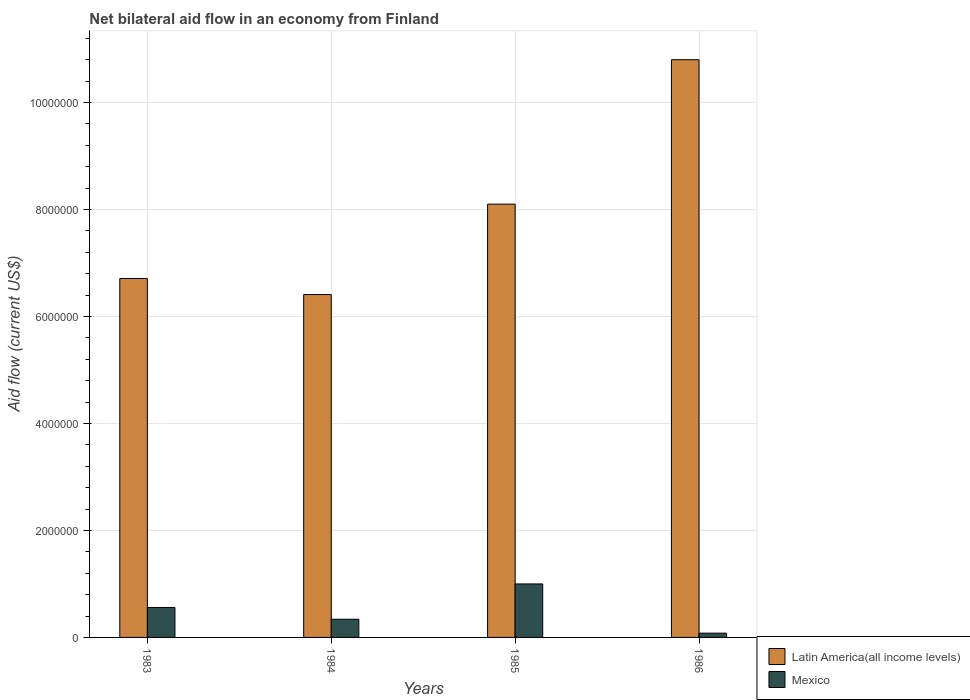How many bars are there on the 3rd tick from the right?
Give a very brief answer. 2. In how many cases, is the number of bars for a given year not equal to the number of legend labels?
Give a very brief answer. 0. Across all years, what is the maximum net bilateral aid flow in Latin America(all income levels)?
Ensure brevity in your answer.  1.08e+07. In which year was the net bilateral aid flow in Mexico maximum?
Keep it short and to the point. 1985. What is the total net bilateral aid flow in Mexico in the graph?
Provide a succinct answer. 1.98e+06. What is the difference between the net bilateral aid flow in Latin America(all income levels) in 1984 and that in 1986?
Provide a short and direct response. -4.39e+06. What is the difference between the net bilateral aid flow in Mexico in 1985 and the net bilateral aid flow in Latin America(all income levels) in 1984?
Keep it short and to the point. -5.41e+06. What is the average net bilateral aid flow in Latin America(all income levels) per year?
Give a very brief answer. 8.00e+06. In the year 1986, what is the difference between the net bilateral aid flow in Latin America(all income levels) and net bilateral aid flow in Mexico?
Your answer should be compact. 1.07e+07. In how many years, is the net bilateral aid flow in Latin America(all income levels) greater than 4400000 US$?
Provide a succinct answer. 4. Is the net bilateral aid flow in Mexico in 1984 less than that in 1985?
Ensure brevity in your answer.  Yes. Is the difference between the net bilateral aid flow in Latin America(all income levels) in 1983 and 1986 greater than the difference between the net bilateral aid flow in Mexico in 1983 and 1986?
Give a very brief answer. No. What is the difference between the highest and the second highest net bilateral aid flow in Mexico?
Offer a very short reply. 4.40e+05. What is the difference between the highest and the lowest net bilateral aid flow in Latin America(all income levels)?
Offer a very short reply. 4.39e+06. In how many years, is the net bilateral aid flow in Mexico greater than the average net bilateral aid flow in Mexico taken over all years?
Give a very brief answer. 2. What does the 1st bar from the right in 1984 represents?
Your response must be concise. Mexico. How many bars are there?
Your answer should be compact. 8. Are all the bars in the graph horizontal?
Offer a terse response. No. What is the difference between two consecutive major ticks on the Y-axis?
Give a very brief answer. 2.00e+06. Does the graph contain grids?
Your answer should be very brief. Yes. Where does the legend appear in the graph?
Provide a short and direct response. Bottom right. What is the title of the graph?
Give a very brief answer. Net bilateral aid flow in an economy from Finland. What is the label or title of the X-axis?
Offer a very short reply. Years. What is the Aid flow (current US$) of Latin America(all income levels) in 1983?
Make the answer very short. 6.71e+06. What is the Aid flow (current US$) in Mexico in 1983?
Your answer should be compact. 5.60e+05. What is the Aid flow (current US$) in Latin America(all income levels) in 1984?
Your answer should be very brief. 6.41e+06. What is the Aid flow (current US$) of Mexico in 1984?
Your answer should be compact. 3.40e+05. What is the Aid flow (current US$) in Latin America(all income levels) in 1985?
Your answer should be compact. 8.10e+06. What is the Aid flow (current US$) of Mexico in 1985?
Your response must be concise. 1.00e+06. What is the Aid flow (current US$) of Latin America(all income levels) in 1986?
Provide a short and direct response. 1.08e+07. What is the Aid flow (current US$) of Mexico in 1986?
Make the answer very short. 8.00e+04. Across all years, what is the maximum Aid flow (current US$) of Latin America(all income levels)?
Your answer should be very brief. 1.08e+07. Across all years, what is the maximum Aid flow (current US$) in Mexico?
Provide a short and direct response. 1.00e+06. Across all years, what is the minimum Aid flow (current US$) in Latin America(all income levels)?
Keep it short and to the point. 6.41e+06. What is the total Aid flow (current US$) of Latin America(all income levels) in the graph?
Provide a short and direct response. 3.20e+07. What is the total Aid flow (current US$) of Mexico in the graph?
Provide a short and direct response. 1.98e+06. What is the difference between the Aid flow (current US$) of Latin America(all income levels) in 1983 and that in 1984?
Give a very brief answer. 3.00e+05. What is the difference between the Aid flow (current US$) in Mexico in 1983 and that in 1984?
Give a very brief answer. 2.20e+05. What is the difference between the Aid flow (current US$) of Latin America(all income levels) in 1983 and that in 1985?
Your answer should be compact. -1.39e+06. What is the difference between the Aid flow (current US$) in Mexico in 1983 and that in 1985?
Your answer should be compact. -4.40e+05. What is the difference between the Aid flow (current US$) in Latin America(all income levels) in 1983 and that in 1986?
Provide a succinct answer. -4.09e+06. What is the difference between the Aid flow (current US$) in Mexico in 1983 and that in 1986?
Your answer should be very brief. 4.80e+05. What is the difference between the Aid flow (current US$) of Latin America(all income levels) in 1984 and that in 1985?
Make the answer very short. -1.69e+06. What is the difference between the Aid flow (current US$) in Mexico in 1984 and that in 1985?
Your answer should be compact. -6.60e+05. What is the difference between the Aid flow (current US$) of Latin America(all income levels) in 1984 and that in 1986?
Keep it short and to the point. -4.39e+06. What is the difference between the Aid flow (current US$) of Latin America(all income levels) in 1985 and that in 1986?
Provide a short and direct response. -2.70e+06. What is the difference between the Aid flow (current US$) in Mexico in 1985 and that in 1986?
Keep it short and to the point. 9.20e+05. What is the difference between the Aid flow (current US$) in Latin America(all income levels) in 1983 and the Aid flow (current US$) in Mexico in 1984?
Your answer should be very brief. 6.37e+06. What is the difference between the Aid flow (current US$) in Latin America(all income levels) in 1983 and the Aid flow (current US$) in Mexico in 1985?
Provide a succinct answer. 5.71e+06. What is the difference between the Aid flow (current US$) of Latin America(all income levels) in 1983 and the Aid flow (current US$) of Mexico in 1986?
Offer a terse response. 6.63e+06. What is the difference between the Aid flow (current US$) of Latin America(all income levels) in 1984 and the Aid flow (current US$) of Mexico in 1985?
Offer a terse response. 5.41e+06. What is the difference between the Aid flow (current US$) of Latin America(all income levels) in 1984 and the Aid flow (current US$) of Mexico in 1986?
Provide a succinct answer. 6.33e+06. What is the difference between the Aid flow (current US$) of Latin America(all income levels) in 1985 and the Aid flow (current US$) of Mexico in 1986?
Give a very brief answer. 8.02e+06. What is the average Aid flow (current US$) of Latin America(all income levels) per year?
Your answer should be very brief. 8.00e+06. What is the average Aid flow (current US$) of Mexico per year?
Make the answer very short. 4.95e+05. In the year 1983, what is the difference between the Aid flow (current US$) in Latin America(all income levels) and Aid flow (current US$) in Mexico?
Ensure brevity in your answer.  6.15e+06. In the year 1984, what is the difference between the Aid flow (current US$) of Latin America(all income levels) and Aid flow (current US$) of Mexico?
Your answer should be very brief. 6.07e+06. In the year 1985, what is the difference between the Aid flow (current US$) of Latin America(all income levels) and Aid flow (current US$) of Mexico?
Keep it short and to the point. 7.10e+06. In the year 1986, what is the difference between the Aid flow (current US$) in Latin America(all income levels) and Aid flow (current US$) in Mexico?
Offer a terse response. 1.07e+07. What is the ratio of the Aid flow (current US$) in Latin America(all income levels) in 1983 to that in 1984?
Ensure brevity in your answer.  1.05. What is the ratio of the Aid flow (current US$) in Mexico in 1983 to that in 1984?
Your answer should be compact. 1.65. What is the ratio of the Aid flow (current US$) of Latin America(all income levels) in 1983 to that in 1985?
Provide a short and direct response. 0.83. What is the ratio of the Aid flow (current US$) of Mexico in 1983 to that in 1985?
Keep it short and to the point. 0.56. What is the ratio of the Aid flow (current US$) of Latin America(all income levels) in 1983 to that in 1986?
Your answer should be very brief. 0.62. What is the ratio of the Aid flow (current US$) of Mexico in 1983 to that in 1986?
Offer a terse response. 7. What is the ratio of the Aid flow (current US$) of Latin America(all income levels) in 1984 to that in 1985?
Give a very brief answer. 0.79. What is the ratio of the Aid flow (current US$) of Mexico in 1984 to that in 1985?
Your answer should be compact. 0.34. What is the ratio of the Aid flow (current US$) of Latin America(all income levels) in 1984 to that in 1986?
Provide a short and direct response. 0.59. What is the ratio of the Aid flow (current US$) in Mexico in 1984 to that in 1986?
Your answer should be compact. 4.25. What is the difference between the highest and the second highest Aid flow (current US$) of Latin America(all income levels)?
Offer a very short reply. 2.70e+06. What is the difference between the highest and the second highest Aid flow (current US$) in Mexico?
Keep it short and to the point. 4.40e+05. What is the difference between the highest and the lowest Aid flow (current US$) in Latin America(all income levels)?
Keep it short and to the point. 4.39e+06. What is the difference between the highest and the lowest Aid flow (current US$) of Mexico?
Your answer should be compact. 9.20e+05. 